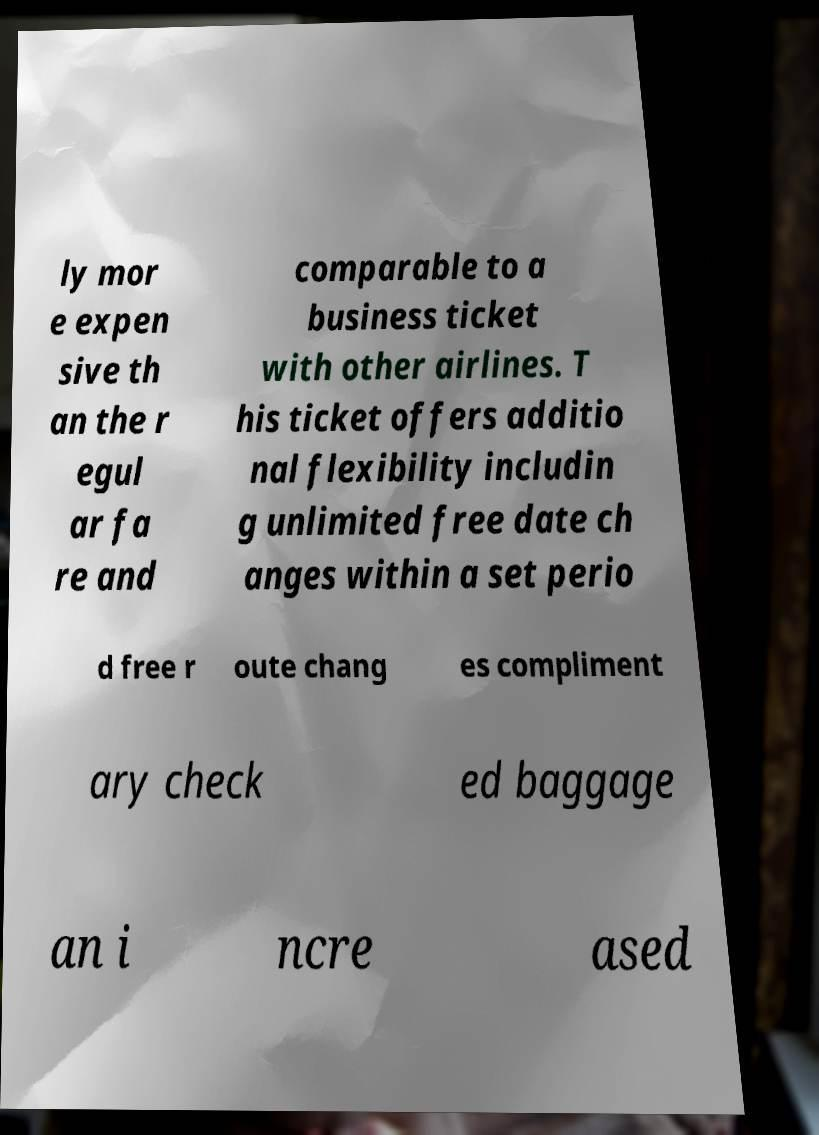For documentation purposes, I need the text within this image transcribed. Could you provide that? ly mor e expen sive th an the r egul ar fa re and comparable to a business ticket with other airlines. T his ticket offers additio nal flexibility includin g unlimited free date ch anges within a set perio d free r oute chang es compliment ary check ed baggage an i ncre ased 